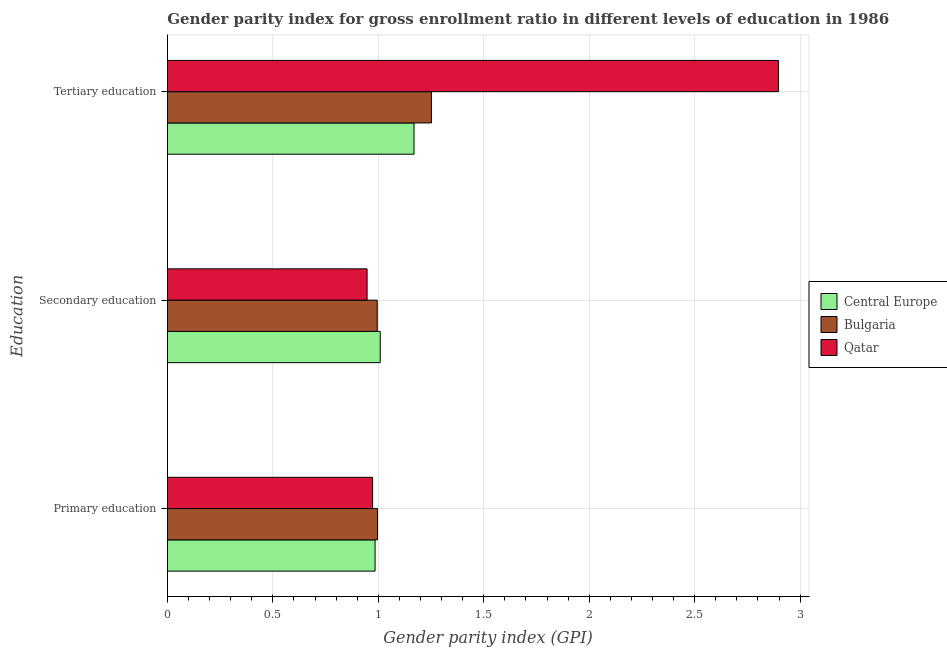How many different coloured bars are there?
Keep it short and to the point. 3. How many groups of bars are there?
Give a very brief answer. 3. How many bars are there on the 2nd tick from the top?
Offer a terse response. 3. How many bars are there on the 3rd tick from the bottom?
Provide a short and direct response. 3. What is the label of the 2nd group of bars from the top?
Provide a short and direct response. Secondary education. What is the gender parity index in secondary education in Bulgaria?
Make the answer very short. 0.99. Across all countries, what is the maximum gender parity index in primary education?
Give a very brief answer. 1. Across all countries, what is the minimum gender parity index in primary education?
Your response must be concise. 0.97. In which country was the gender parity index in tertiary education maximum?
Offer a terse response. Qatar. In which country was the gender parity index in tertiary education minimum?
Offer a very short reply. Central Europe. What is the total gender parity index in tertiary education in the graph?
Provide a short and direct response. 5.32. What is the difference between the gender parity index in primary education in Bulgaria and that in Central Europe?
Make the answer very short. 0.01. What is the difference between the gender parity index in primary education in Central Europe and the gender parity index in tertiary education in Qatar?
Keep it short and to the point. -1.91. What is the average gender parity index in secondary education per country?
Ensure brevity in your answer.  0.98. What is the difference between the gender parity index in tertiary education and gender parity index in primary education in Bulgaria?
Provide a short and direct response. 0.26. What is the ratio of the gender parity index in tertiary education in Qatar to that in Central Europe?
Make the answer very short. 2.48. Is the gender parity index in primary education in Qatar less than that in Central Europe?
Offer a terse response. Yes. What is the difference between the highest and the second highest gender parity index in tertiary education?
Your response must be concise. 1.65. What is the difference between the highest and the lowest gender parity index in tertiary education?
Provide a succinct answer. 1.73. What does the 3rd bar from the top in Tertiary education represents?
Offer a terse response. Central Europe. What does the 1st bar from the bottom in Primary education represents?
Give a very brief answer. Central Europe. Is it the case that in every country, the sum of the gender parity index in primary education and gender parity index in secondary education is greater than the gender parity index in tertiary education?
Make the answer very short. No. How many bars are there?
Offer a very short reply. 9. Are all the bars in the graph horizontal?
Provide a succinct answer. Yes. How many countries are there in the graph?
Offer a terse response. 3. What is the difference between two consecutive major ticks on the X-axis?
Provide a succinct answer. 0.5. How many legend labels are there?
Keep it short and to the point. 3. What is the title of the graph?
Ensure brevity in your answer.  Gender parity index for gross enrollment ratio in different levels of education in 1986. What is the label or title of the X-axis?
Offer a very short reply. Gender parity index (GPI). What is the label or title of the Y-axis?
Ensure brevity in your answer.  Education. What is the Gender parity index (GPI) in Central Europe in Primary education?
Offer a terse response. 0.98. What is the Gender parity index (GPI) of Bulgaria in Primary education?
Provide a short and direct response. 1. What is the Gender parity index (GPI) in Qatar in Primary education?
Ensure brevity in your answer.  0.97. What is the Gender parity index (GPI) in Central Europe in Secondary education?
Offer a terse response. 1.01. What is the Gender parity index (GPI) of Bulgaria in Secondary education?
Give a very brief answer. 0.99. What is the Gender parity index (GPI) in Qatar in Secondary education?
Offer a terse response. 0.95. What is the Gender parity index (GPI) in Central Europe in Tertiary education?
Make the answer very short. 1.17. What is the Gender parity index (GPI) in Bulgaria in Tertiary education?
Offer a very short reply. 1.25. What is the Gender parity index (GPI) in Qatar in Tertiary education?
Provide a succinct answer. 2.9. Across all Education, what is the maximum Gender parity index (GPI) of Central Europe?
Provide a short and direct response. 1.17. Across all Education, what is the maximum Gender parity index (GPI) of Bulgaria?
Offer a very short reply. 1.25. Across all Education, what is the maximum Gender parity index (GPI) in Qatar?
Provide a short and direct response. 2.9. Across all Education, what is the minimum Gender parity index (GPI) in Central Europe?
Offer a terse response. 0.98. Across all Education, what is the minimum Gender parity index (GPI) in Bulgaria?
Offer a very short reply. 0.99. Across all Education, what is the minimum Gender parity index (GPI) in Qatar?
Your answer should be compact. 0.95. What is the total Gender parity index (GPI) of Central Europe in the graph?
Offer a terse response. 3.16. What is the total Gender parity index (GPI) of Bulgaria in the graph?
Provide a succinct answer. 3.24. What is the total Gender parity index (GPI) in Qatar in the graph?
Your response must be concise. 4.82. What is the difference between the Gender parity index (GPI) of Central Europe in Primary education and that in Secondary education?
Provide a short and direct response. -0.02. What is the difference between the Gender parity index (GPI) in Bulgaria in Primary education and that in Secondary education?
Offer a terse response. 0. What is the difference between the Gender parity index (GPI) in Qatar in Primary education and that in Secondary education?
Offer a very short reply. 0.03. What is the difference between the Gender parity index (GPI) of Central Europe in Primary education and that in Tertiary education?
Offer a very short reply. -0.18. What is the difference between the Gender parity index (GPI) of Bulgaria in Primary education and that in Tertiary education?
Give a very brief answer. -0.26. What is the difference between the Gender parity index (GPI) in Qatar in Primary education and that in Tertiary education?
Keep it short and to the point. -1.92. What is the difference between the Gender parity index (GPI) of Central Europe in Secondary education and that in Tertiary education?
Keep it short and to the point. -0.16. What is the difference between the Gender parity index (GPI) in Bulgaria in Secondary education and that in Tertiary education?
Your answer should be compact. -0.26. What is the difference between the Gender parity index (GPI) of Qatar in Secondary education and that in Tertiary education?
Offer a very short reply. -1.95. What is the difference between the Gender parity index (GPI) of Central Europe in Primary education and the Gender parity index (GPI) of Bulgaria in Secondary education?
Provide a short and direct response. -0.01. What is the difference between the Gender parity index (GPI) in Central Europe in Primary education and the Gender parity index (GPI) in Qatar in Secondary education?
Your answer should be very brief. 0.04. What is the difference between the Gender parity index (GPI) of Bulgaria in Primary education and the Gender parity index (GPI) of Qatar in Secondary education?
Offer a terse response. 0.05. What is the difference between the Gender parity index (GPI) in Central Europe in Primary education and the Gender parity index (GPI) in Bulgaria in Tertiary education?
Offer a very short reply. -0.27. What is the difference between the Gender parity index (GPI) of Central Europe in Primary education and the Gender parity index (GPI) of Qatar in Tertiary education?
Provide a succinct answer. -1.91. What is the difference between the Gender parity index (GPI) of Bulgaria in Primary education and the Gender parity index (GPI) of Qatar in Tertiary education?
Make the answer very short. -1.9. What is the difference between the Gender parity index (GPI) of Central Europe in Secondary education and the Gender parity index (GPI) of Bulgaria in Tertiary education?
Give a very brief answer. -0.24. What is the difference between the Gender parity index (GPI) of Central Europe in Secondary education and the Gender parity index (GPI) of Qatar in Tertiary education?
Keep it short and to the point. -1.89. What is the difference between the Gender parity index (GPI) in Bulgaria in Secondary education and the Gender parity index (GPI) in Qatar in Tertiary education?
Your answer should be compact. -1.9. What is the average Gender parity index (GPI) of Central Europe per Education?
Offer a very short reply. 1.05. What is the average Gender parity index (GPI) of Bulgaria per Education?
Ensure brevity in your answer.  1.08. What is the average Gender parity index (GPI) in Qatar per Education?
Provide a succinct answer. 1.61. What is the difference between the Gender parity index (GPI) of Central Europe and Gender parity index (GPI) of Bulgaria in Primary education?
Your response must be concise. -0.01. What is the difference between the Gender parity index (GPI) in Central Europe and Gender parity index (GPI) in Qatar in Primary education?
Provide a succinct answer. 0.01. What is the difference between the Gender parity index (GPI) in Bulgaria and Gender parity index (GPI) in Qatar in Primary education?
Keep it short and to the point. 0.02. What is the difference between the Gender parity index (GPI) in Central Europe and Gender parity index (GPI) in Bulgaria in Secondary education?
Offer a terse response. 0.01. What is the difference between the Gender parity index (GPI) of Central Europe and Gender parity index (GPI) of Qatar in Secondary education?
Provide a short and direct response. 0.06. What is the difference between the Gender parity index (GPI) in Bulgaria and Gender parity index (GPI) in Qatar in Secondary education?
Your response must be concise. 0.05. What is the difference between the Gender parity index (GPI) of Central Europe and Gender parity index (GPI) of Bulgaria in Tertiary education?
Ensure brevity in your answer.  -0.08. What is the difference between the Gender parity index (GPI) of Central Europe and Gender parity index (GPI) of Qatar in Tertiary education?
Give a very brief answer. -1.73. What is the difference between the Gender parity index (GPI) of Bulgaria and Gender parity index (GPI) of Qatar in Tertiary education?
Offer a terse response. -1.65. What is the ratio of the Gender parity index (GPI) of Central Europe in Primary education to that in Secondary education?
Ensure brevity in your answer.  0.98. What is the ratio of the Gender parity index (GPI) in Qatar in Primary education to that in Secondary education?
Provide a succinct answer. 1.03. What is the ratio of the Gender parity index (GPI) in Central Europe in Primary education to that in Tertiary education?
Give a very brief answer. 0.84. What is the ratio of the Gender parity index (GPI) in Bulgaria in Primary education to that in Tertiary education?
Your answer should be compact. 0.8. What is the ratio of the Gender parity index (GPI) in Qatar in Primary education to that in Tertiary education?
Your answer should be very brief. 0.34. What is the ratio of the Gender parity index (GPI) of Central Europe in Secondary education to that in Tertiary education?
Offer a terse response. 0.86. What is the ratio of the Gender parity index (GPI) of Bulgaria in Secondary education to that in Tertiary education?
Offer a very short reply. 0.79. What is the ratio of the Gender parity index (GPI) of Qatar in Secondary education to that in Tertiary education?
Your answer should be very brief. 0.33. What is the difference between the highest and the second highest Gender parity index (GPI) of Central Europe?
Your response must be concise. 0.16. What is the difference between the highest and the second highest Gender parity index (GPI) of Bulgaria?
Your response must be concise. 0.26. What is the difference between the highest and the second highest Gender parity index (GPI) in Qatar?
Offer a terse response. 1.92. What is the difference between the highest and the lowest Gender parity index (GPI) in Central Europe?
Keep it short and to the point. 0.18. What is the difference between the highest and the lowest Gender parity index (GPI) of Bulgaria?
Make the answer very short. 0.26. What is the difference between the highest and the lowest Gender parity index (GPI) in Qatar?
Offer a terse response. 1.95. 